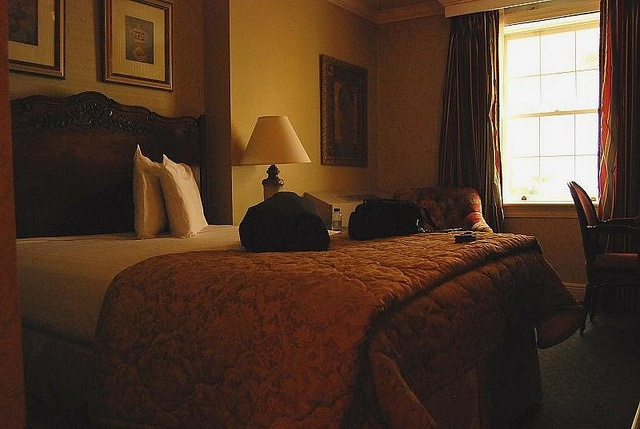Describe the objects in this image and their specific colors. I can see bed in maroon, black, and brown tones, suitcase in maroon, black, and tan tones, chair in maroon, black, brown, and gray tones, and suitcase in maroon, black, and gray tones in this image. 